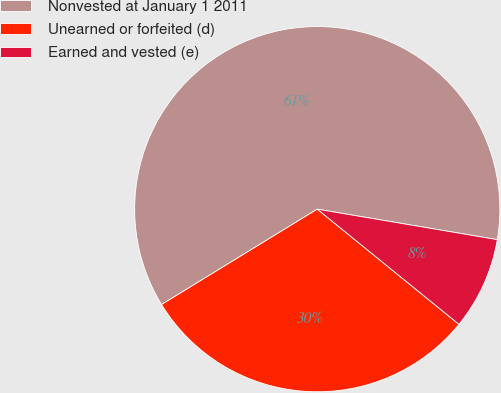Convert chart. <chart><loc_0><loc_0><loc_500><loc_500><pie_chart><fcel>Nonvested at January 1 2011<fcel>Unearned or forfeited (d)<fcel>Earned and vested (e)<nl><fcel>61.42%<fcel>30.39%<fcel>8.19%<nl></chart> 